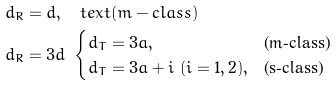Convert formula to latex. <formula><loc_0><loc_0><loc_500><loc_500>& d _ { R } = d , \quad t e x t { ( m - c l a s s ) } \\ & d _ { R } = 3 d \ \begin{cases} d _ { T } = 3 a , \ \ & \text {(m-class)} \\ d _ { T } = 3 a + i \ ( i = 1 , 2 ) , & \text {(s-class)} \end{cases}</formula> 